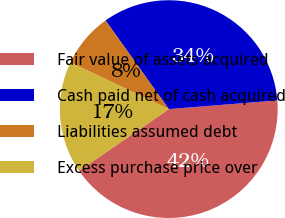<chart> <loc_0><loc_0><loc_500><loc_500><pie_chart><fcel>Fair value of assets acquired<fcel>Cash paid net of cash acquired<fcel>Liabilities assumed debt<fcel>Excess purchase price over<nl><fcel>41.68%<fcel>33.59%<fcel>8.09%<fcel>16.64%<nl></chart> 